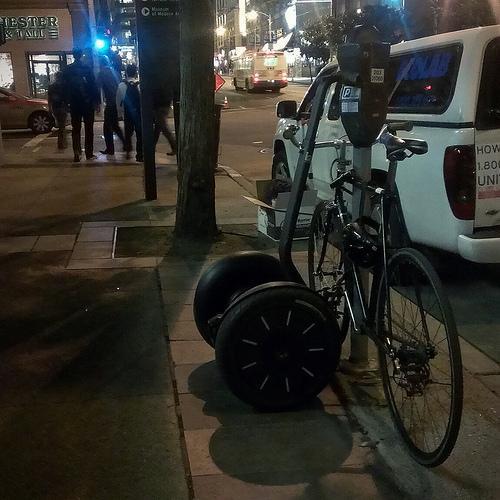How many bicycles are pictured?
Give a very brief answer. 1. How many bicycles are leaning against the parking meter?
Give a very brief answer. 1. 